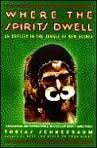Is this book related to Politics & Social Sciences? No, this book primarily explores travel and adventure themes rather than delving into topics of politics or social sciences. 